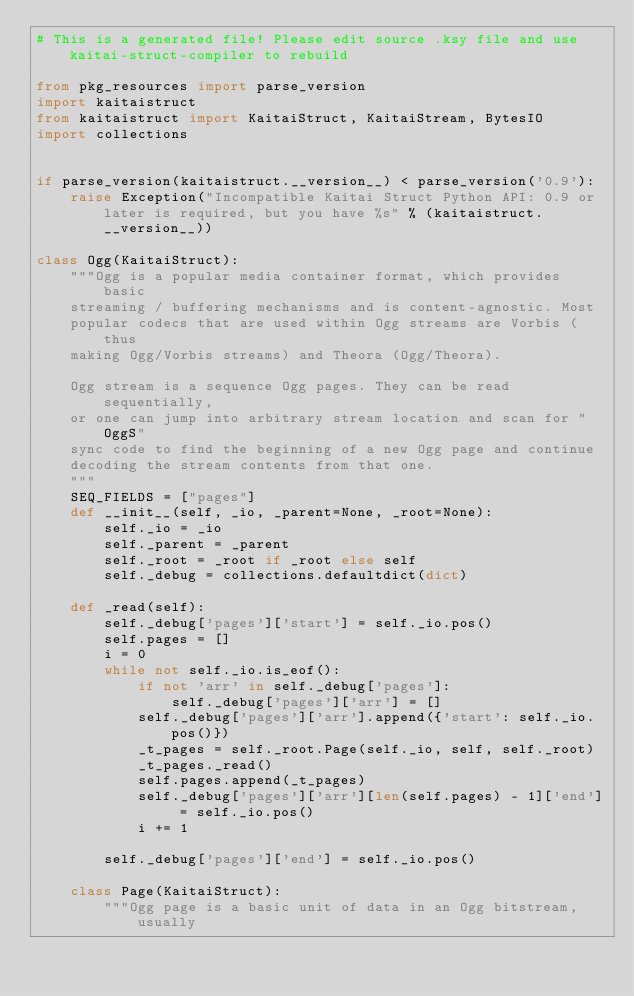<code> <loc_0><loc_0><loc_500><loc_500><_Python_># This is a generated file! Please edit source .ksy file and use kaitai-struct-compiler to rebuild

from pkg_resources import parse_version
import kaitaistruct
from kaitaistruct import KaitaiStruct, KaitaiStream, BytesIO
import collections


if parse_version(kaitaistruct.__version__) < parse_version('0.9'):
    raise Exception("Incompatible Kaitai Struct Python API: 0.9 or later is required, but you have %s" % (kaitaistruct.__version__))

class Ogg(KaitaiStruct):
    """Ogg is a popular media container format, which provides basic
    streaming / buffering mechanisms and is content-agnostic. Most
    popular codecs that are used within Ogg streams are Vorbis (thus
    making Ogg/Vorbis streams) and Theora (Ogg/Theora).
    
    Ogg stream is a sequence Ogg pages. They can be read sequentially,
    or one can jump into arbitrary stream location and scan for "OggS"
    sync code to find the beginning of a new Ogg page and continue
    decoding the stream contents from that one.
    """
    SEQ_FIELDS = ["pages"]
    def __init__(self, _io, _parent=None, _root=None):
        self._io = _io
        self._parent = _parent
        self._root = _root if _root else self
        self._debug = collections.defaultdict(dict)

    def _read(self):
        self._debug['pages']['start'] = self._io.pos()
        self.pages = []
        i = 0
        while not self._io.is_eof():
            if not 'arr' in self._debug['pages']:
                self._debug['pages']['arr'] = []
            self._debug['pages']['arr'].append({'start': self._io.pos()})
            _t_pages = self._root.Page(self._io, self, self._root)
            _t_pages._read()
            self.pages.append(_t_pages)
            self._debug['pages']['arr'][len(self.pages) - 1]['end'] = self._io.pos()
            i += 1

        self._debug['pages']['end'] = self._io.pos()

    class Page(KaitaiStruct):
        """Ogg page is a basic unit of data in an Ogg bitstream, usually</code> 